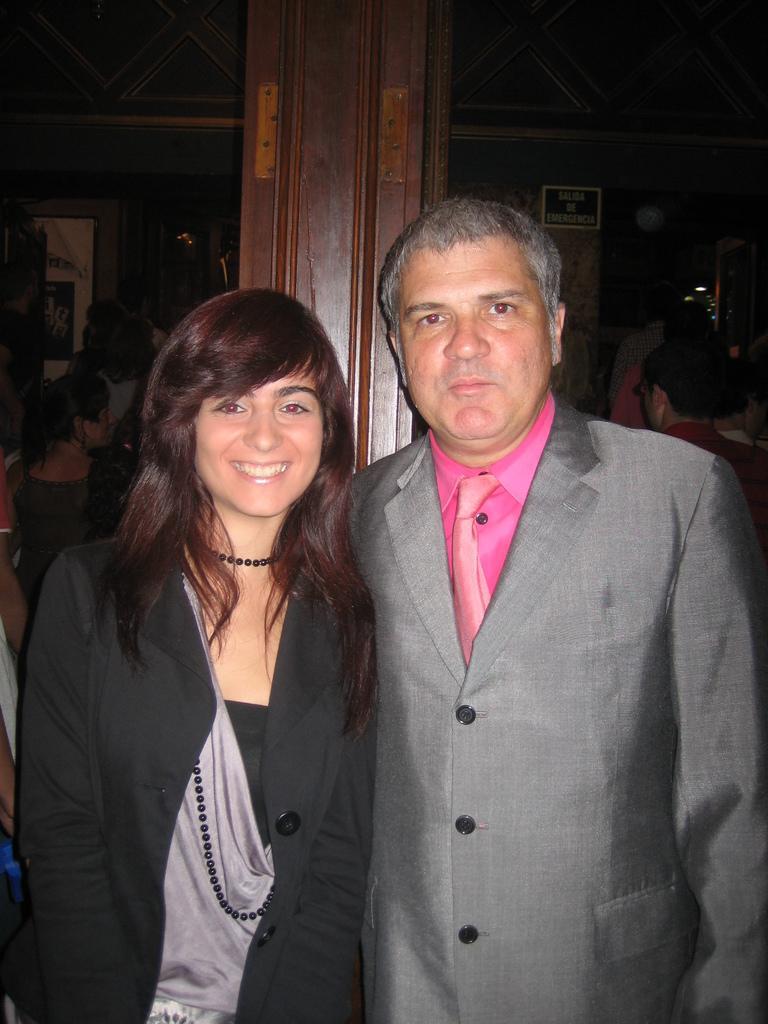Could you give a brief overview of what you see in this image? There are two persons standing as we can see in the middle of this image and there is a wall and some persons in the background. There is a wooden pillar is at the top of this image. 